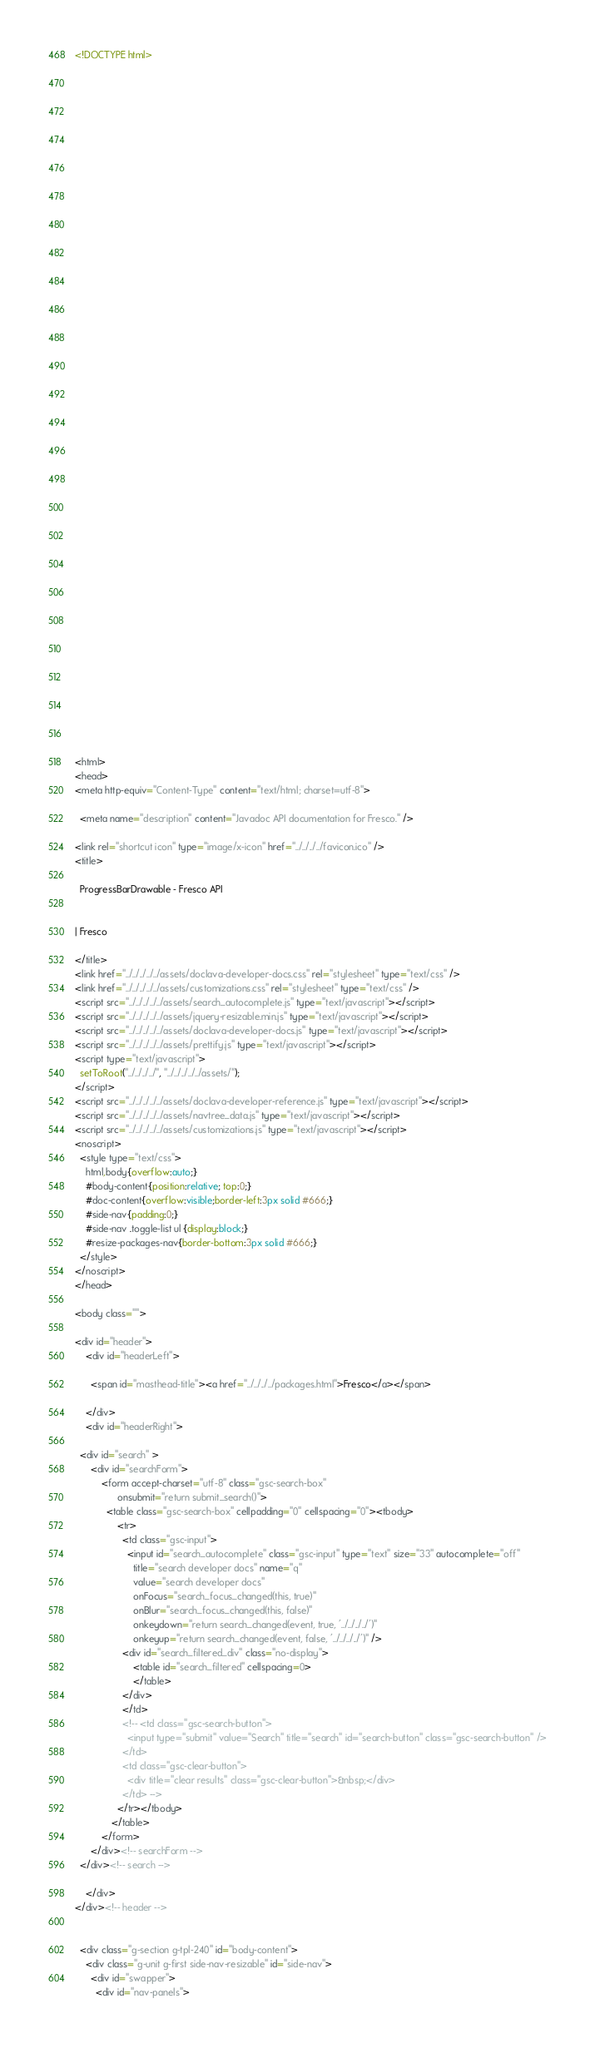<code> <loc_0><loc_0><loc_500><loc_500><_HTML_><!DOCTYPE html>

















































<html>
<head>
<meta http-equiv="Content-Type" content="text/html; charset=utf-8">

  <meta name="description" content="Javadoc API documentation for Fresco." />

<link rel="shortcut icon" type="image/x-icon" href="../../../../favicon.ico" />
<title>

  ProgressBarDrawable - Fresco API


| Fresco

</title>
<link href="../../../../../assets/doclava-developer-docs.css" rel="stylesheet" type="text/css" />
<link href="../../../../../assets/customizations.css" rel="stylesheet" type="text/css" />
<script src="../../../../../assets/search_autocomplete.js" type="text/javascript"></script>
<script src="../../../../../assets/jquery-resizable.min.js" type="text/javascript"></script>
<script src="../../../../../assets/doclava-developer-docs.js" type="text/javascript"></script>
<script src="../../../../../assets/prettify.js" type="text/javascript"></script>
<script type="text/javascript">
  setToRoot("../../../../", "../../../../../assets/");
</script>
<script src="../../../../../assets/doclava-developer-reference.js" type="text/javascript"></script>
<script src="../../../../../assets/navtree_data.js" type="text/javascript"></script>
<script src="../../../../../assets/customizations.js" type="text/javascript"></script>
<noscript>
  <style type="text/css">
    html,body{overflow:auto;}
    #body-content{position:relative; top:0;}
    #doc-content{overflow:visible;border-left:3px solid #666;}
    #side-nav{padding:0;}
    #side-nav .toggle-list ul {display:block;}
    #resize-packages-nav{border-bottom:3px solid #666;}
  </style>
</noscript>
</head>

<body class="">

<div id="header">
    <div id="headerLeft">
    
      <span id="masthead-title"><a href="../../../../packages.html">Fresco</a></span>
    
    </div>
    <div id="headerRight">
      
  <div id="search" >
      <div id="searchForm">
          <form accept-charset="utf-8" class="gsc-search-box" 
                onsubmit="return submit_search()">
            <table class="gsc-search-box" cellpadding="0" cellspacing="0"><tbody>
                <tr>
                  <td class="gsc-input">
                    <input id="search_autocomplete" class="gsc-input" type="text" size="33" autocomplete="off"
                      title="search developer docs" name="q"
                      value="search developer docs"
                      onFocus="search_focus_changed(this, true)"
                      onBlur="search_focus_changed(this, false)"
                      onkeydown="return search_changed(event, true, '../../../../')"
                      onkeyup="return search_changed(event, false, '../../../../')" />
                  <div id="search_filtered_div" class="no-display">
                      <table id="search_filtered" cellspacing=0>
                      </table>
                  </div>
                  </td>
                  <!-- <td class="gsc-search-button">
                    <input type="submit" value="Search" title="search" id="search-button" class="gsc-search-button" />
                  </td>
                  <td class="gsc-clear-button">
                    <div title="clear results" class="gsc-clear-button">&nbsp;</div>
                  </td> -->
                </tr></tbody>
              </table>
          </form>
      </div><!-- searchForm -->
  </div><!-- search -->
      
    </div>
</div><!-- header -->


  <div class="g-section g-tpl-240" id="body-content">
    <div class="g-unit g-first side-nav-resizable" id="side-nav">
      <div id="swapper">
        <div id="nav-panels"></code> 